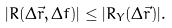Convert formula to latex. <formula><loc_0><loc_0><loc_500><loc_500>| R ( \Delta \vec { r } , \Delta f ) | \leq | R _ { Y } ( \Delta \vec { r } ) | .</formula> 